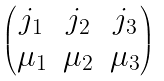<formula> <loc_0><loc_0><loc_500><loc_500>\begin{pmatrix} j _ { 1 } & j _ { 2 } & j _ { 3 } \\ \mu _ { 1 } & \mu _ { 2 } & \mu _ { 3 } \end{pmatrix}</formula> 